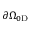Convert formula to latex. <formula><loc_0><loc_0><loc_500><loc_500>\partial \Omega _ { 0 D }</formula> 